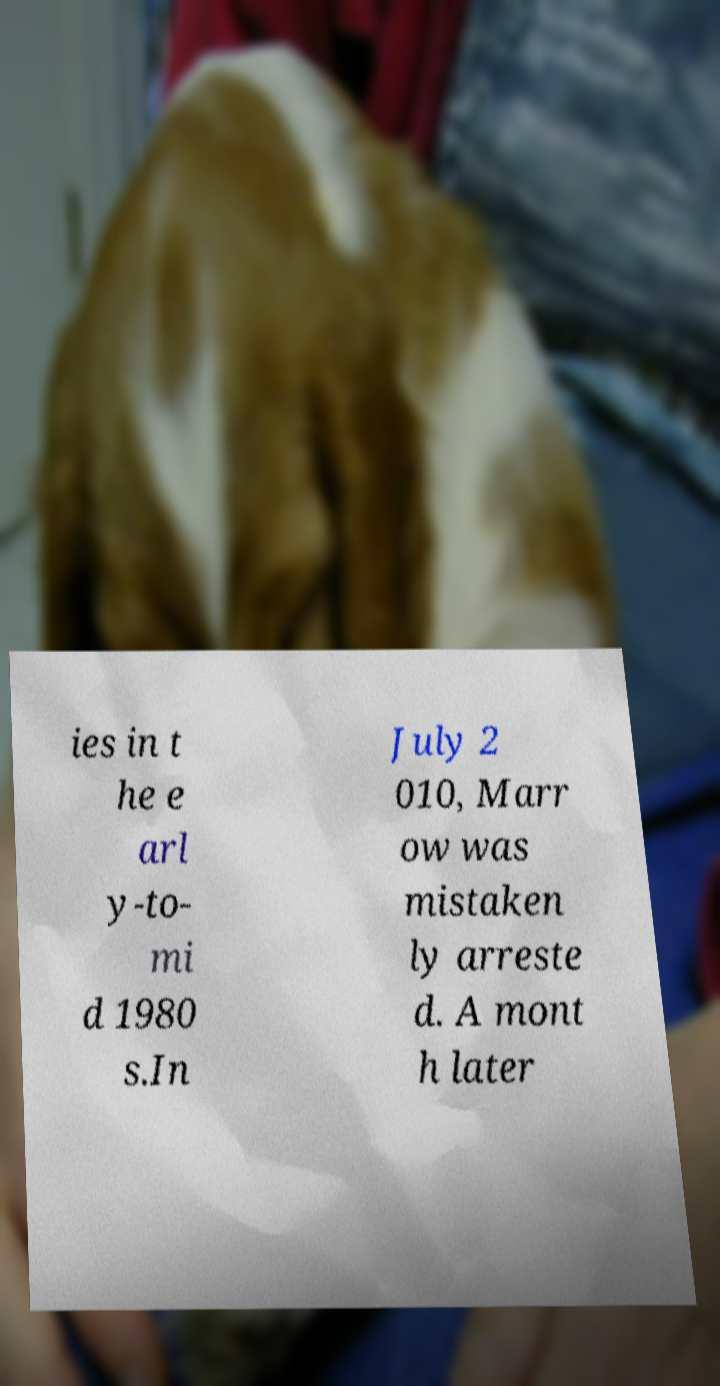Please identify and transcribe the text found in this image. ies in t he e arl y-to- mi d 1980 s.In July 2 010, Marr ow was mistaken ly arreste d. A mont h later 